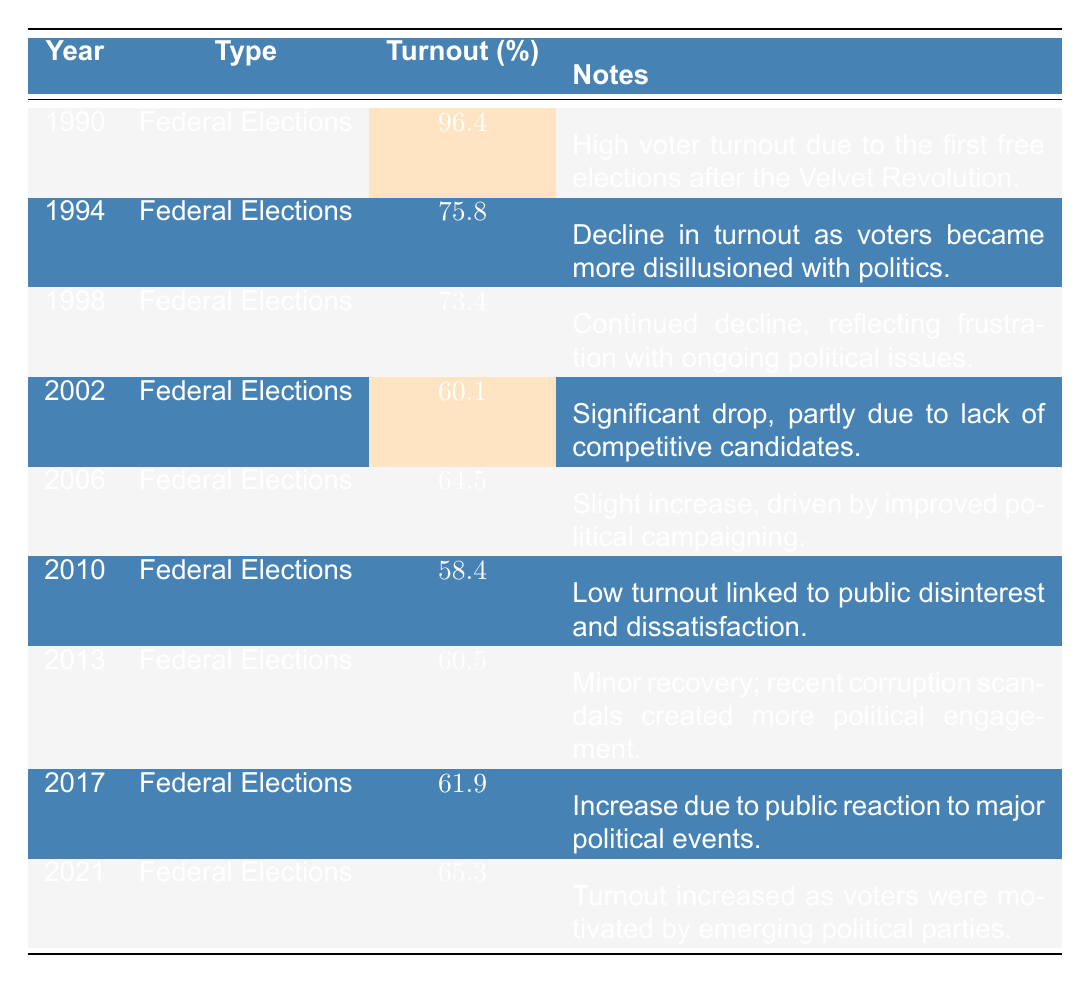What was the voter turnout percentage in the 1990 Federal Elections? The table shows that the voter turnout percentage for the 1990 Federal Elections is 96.4%.
Answer: 96.4% Which election year had the lowest voter turnout percentage? The table indicates that the lowest voter turnout percentage was in 2010 at 58.4%.
Answer: 2010 What was the difference in voter turnout between 1994 and 1998? The voter turnout in 1994 was 75.8% and in 1998 it was 73.4%. The difference is 75.8 - 73.4 = 2.4%.
Answer: 2.4% Is the statement "Voter turnout increased from 2002 to 2006" true or false? The table shows that the voter turnout in 2002 was 60.1% and in 2006 it was 64.5%. Therefore, it increased, making the statement true.
Answer: True What is the average voter turnout percentage from 1990 to 2021? The percentages for the years are 96.4, 75.8, 73.4, 60.1, 64.5, 58.4, 60.5, 61.9, and 65.3. Summing these gives 96.4 + 75.8 + 73.4 + 60.1 + 64.5 + 58.4 + 60.5 + 61.9 + 65.3 = 576.3. Dividing 576.3 by 9 (the number of elections) gives an average of approximately 64.0%.
Answer: 64.0% Which election year saw a recovery in voter turnout after several declines? According to the table, 2013 showed a minor recovery in voter turnout, increasing to 60.5% compared to 58.4% in 2010.
Answer: 2013 What was the trend in voter turnout percentages from 1990 to 2002? The trend shows a general decline: starting at 96.4%, it drops in subsequent elections to reach 60.1% by 2002.
Answer: Decline How many elections had a voter turnout percentage below 65%? The table listings show that the percentages below 65% occurred in 2002 (60.1%), 2010 (58.4%), and 2013 (60.5%), giving a total of 3 elections.
Answer: 3 Was there an increase in voter turnout from 2013 to 2021? The voter turnout in 2013 was 60.5% and increased to 65.3% in 2021, indicating an increase between these years.
Answer: Yes What can be inferred about the relationship between the first free elections and voter turnout? The table shows a high turnout of 96.4% in 1990 due to the first free elections after the Velvet Revolution, suggesting a strong initial political engagement.
Answer: High engagement Which election years had over 60% voter turnout? The election years with over 60% turnout are 1990 (96.4%), 1994 (75.8%), 1998 (73.4%), 2006 (64.5%), 2013 (60.5%), 2017 (61.9%), and 2021 (65.3%). This totals 7 years.
Answer: 7 years 